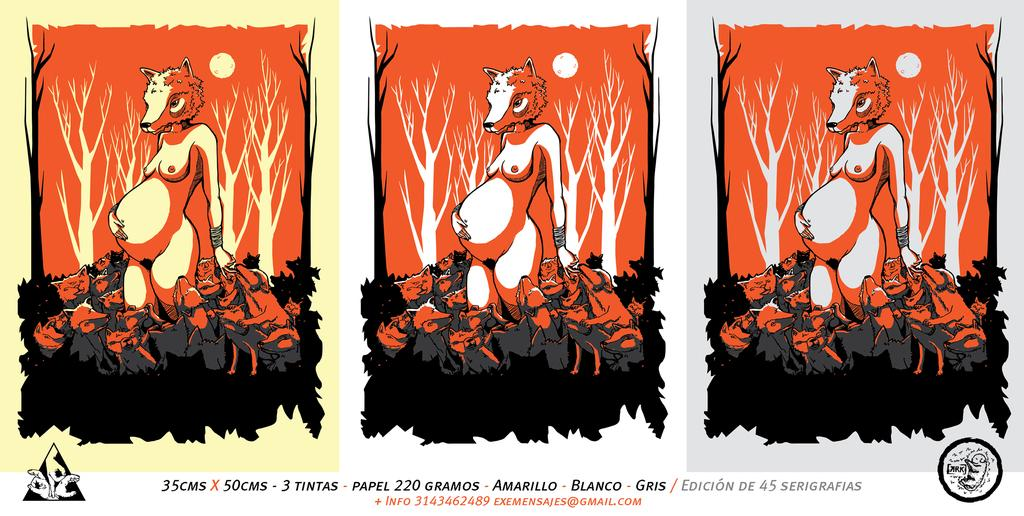<image>
Offer a succinct explanation of the picture presented. Three identical drawings of a pregnant creature in the woods are 35 cms X 50cms and are for sale. 